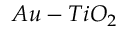<formula> <loc_0><loc_0><loc_500><loc_500>A u - T i O _ { 2 }</formula> 